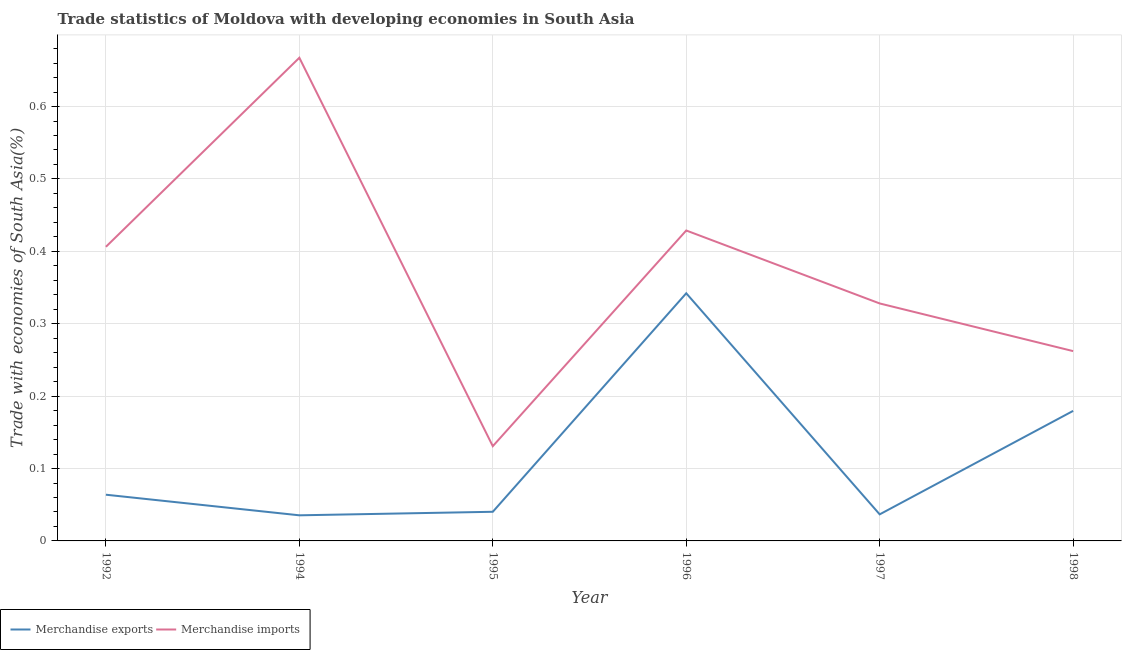Is the number of lines equal to the number of legend labels?
Make the answer very short. Yes. What is the merchandise imports in 1996?
Offer a terse response. 0.43. Across all years, what is the maximum merchandise imports?
Keep it short and to the point. 0.67. Across all years, what is the minimum merchandise imports?
Keep it short and to the point. 0.13. What is the total merchandise imports in the graph?
Ensure brevity in your answer.  2.22. What is the difference between the merchandise exports in 1992 and that in 1998?
Make the answer very short. -0.12. What is the difference between the merchandise imports in 1997 and the merchandise exports in 1996?
Ensure brevity in your answer.  -0.01. What is the average merchandise exports per year?
Make the answer very short. 0.12. In the year 1998, what is the difference between the merchandise exports and merchandise imports?
Provide a short and direct response. -0.08. What is the ratio of the merchandise exports in 1992 to that in 1997?
Keep it short and to the point. 1.74. Is the difference between the merchandise imports in 1995 and 1998 greater than the difference between the merchandise exports in 1995 and 1998?
Your answer should be compact. Yes. What is the difference between the highest and the second highest merchandise imports?
Provide a short and direct response. 0.24. What is the difference between the highest and the lowest merchandise exports?
Provide a succinct answer. 0.31. Is the sum of the merchandise exports in 1994 and 1996 greater than the maximum merchandise imports across all years?
Keep it short and to the point. No. Does the merchandise exports monotonically increase over the years?
Your answer should be compact. No. Is the merchandise exports strictly greater than the merchandise imports over the years?
Your response must be concise. No. Are the values on the major ticks of Y-axis written in scientific E-notation?
Your response must be concise. No. Does the graph contain any zero values?
Offer a terse response. No. Does the graph contain grids?
Provide a succinct answer. Yes. Where does the legend appear in the graph?
Ensure brevity in your answer.  Bottom left. How many legend labels are there?
Your answer should be very brief. 2. What is the title of the graph?
Your response must be concise. Trade statistics of Moldova with developing economies in South Asia. What is the label or title of the X-axis?
Offer a very short reply. Year. What is the label or title of the Y-axis?
Provide a succinct answer. Trade with economies of South Asia(%). What is the Trade with economies of South Asia(%) of Merchandise exports in 1992?
Keep it short and to the point. 0.06. What is the Trade with economies of South Asia(%) in Merchandise imports in 1992?
Offer a very short reply. 0.41. What is the Trade with economies of South Asia(%) of Merchandise exports in 1994?
Make the answer very short. 0.04. What is the Trade with economies of South Asia(%) of Merchandise imports in 1994?
Keep it short and to the point. 0.67. What is the Trade with economies of South Asia(%) in Merchandise exports in 1995?
Offer a terse response. 0.04. What is the Trade with economies of South Asia(%) in Merchandise imports in 1995?
Keep it short and to the point. 0.13. What is the Trade with economies of South Asia(%) of Merchandise exports in 1996?
Make the answer very short. 0.34. What is the Trade with economies of South Asia(%) of Merchandise imports in 1996?
Provide a short and direct response. 0.43. What is the Trade with economies of South Asia(%) of Merchandise exports in 1997?
Your response must be concise. 0.04. What is the Trade with economies of South Asia(%) of Merchandise imports in 1997?
Provide a short and direct response. 0.33. What is the Trade with economies of South Asia(%) in Merchandise exports in 1998?
Provide a succinct answer. 0.18. What is the Trade with economies of South Asia(%) in Merchandise imports in 1998?
Keep it short and to the point. 0.26. Across all years, what is the maximum Trade with economies of South Asia(%) of Merchandise exports?
Your answer should be compact. 0.34. Across all years, what is the maximum Trade with economies of South Asia(%) in Merchandise imports?
Your answer should be compact. 0.67. Across all years, what is the minimum Trade with economies of South Asia(%) in Merchandise exports?
Your answer should be very brief. 0.04. Across all years, what is the minimum Trade with economies of South Asia(%) of Merchandise imports?
Provide a short and direct response. 0.13. What is the total Trade with economies of South Asia(%) of Merchandise exports in the graph?
Your answer should be very brief. 0.7. What is the total Trade with economies of South Asia(%) in Merchandise imports in the graph?
Provide a short and direct response. 2.22. What is the difference between the Trade with economies of South Asia(%) in Merchandise exports in 1992 and that in 1994?
Ensure brevity in your answer.  0.03. What is the difference between the Trade with economies of South Asia(%) in Merchandise imports in 1992 and that in 1994?
Ensure brevity in your answer.  -0.26. What is the difference between the Trade with economies of South Asia(%) in Merchandise exports in 1992 and that in 1995?
Keep it short and to the point. 0.02. What is the difference between the Trade with economies of South Asia(%) of Merchandise imports in 1992 and that in 1995?
Your answer should be very brief. 0.28. What is the difference between the Trade with economies of South Asia(%) in Merchandise exports in 1992 and that in 1996?
Your answer should be very brief. -0.28. What is the difference between the Trade with economies of South Asia(%) in Merchandise imports in 1992 and that in 1996?
Give a very brief answer. -0.02. What is the difference between the Trade with economies of South Asia(%) of Merchandise exports in 1992 and that in 1997?
Provide a short and direct response. 0.03. What is the difference between the Trade with economies of South Asia(%) of Merchandise imports in 1992 and that in 1997?
Offer a terse response. 0.08. What is the difference between the Trade with economies of South Asia(%) of Merchandise exports in 1992 and that in 1998?
Offer a terse response. -0.12. What is the difference between the Trade with economies of South Asia(%) in Merchandise imports in 1992 and that in 1998?
Give a very brief answer. 0.14. What is the difference between the Trade with economies of South Asia(%) in Merchandise exports in 1994 and that in 1995?
Offer a very short reply. -0. What is the difference between the Trade with economies of South Asia(%) of Merchandise imports in 1994 and that in 1995?
Provide a short and direct response. 0.54. What is the difference between the Trade with economies of South Asia(%) in Merchandise exports in 1994 and that in 1996?
Ensure brevity in your answer.  -0.31. What is the difference between the Trade with economies of South Asia(%) of Merchandise imports in 1994 and that in 1996?
Your answer should be compact. 0.24. What is the difference between the Trade with economies of South Asia(%) in Merchandise exports in 1994 and that in 1997?
Offer a very short reply. -0. What is the difference between the Trade with economies of South Asia(%) of Merchandise imports in 1994 and that in 1997?
Provide a succinct answer. 0.34. What is the difference between the Trade with economies of South Asia(%) of Merchandise exports in 1994 and that in 1998?
Offer a very short reply. -0.14. What is the difference between the Trade with economies of South Asia(%) of Merchandise imports in 1994 and that in 1998?
Your answer should be compact. 0.41. What is the difference between the Trade with economies of South Asia(%) of Merchandise exports in 1995 and that in 1996?
Your response must be concise. -0.3. What is the difference between the Trade with economies of South Asia(%) in Merchandise imports in 1995 and that in 1996?
Offer a very short reply. -0.3. What is the difference between the Trade with economies of South Asia(%) of Merchandise exports in 1995 and that in 1997?
Your answer should be very brief. 0. What is the difference between the Trade with economies of South Asia(%) of Merchandise imports in 1995 and that in 1997?
Your answer should be very brief. -0.2. What is the difference between the Trade with economies of South Asia(%) in Merchandise exports in 1995 and that in 1998?
Your answer should be very brief. -0.14. What is the difference between the Trade with economies of South Asia(%) in Merchandise imports in 1995 and that in 1998?
Keep it short and to the point. -0.13. What is the difference between the Trade with economies of South Asia(%) of Merchandise exports in 1996 and that in 1997?
Ensure brevity in your answer.  0.31. What is the difference between the Trade with economies of South Asia(%) in Merchandise imports in 1996 and that in 1997?
Keep it short and to the point. 0.1. What is the difference between the Trade with economies of South Asia(%) in Merchandise exports in 1996 and that in 1998?
Offer a terse response. 0.16. What is the difference between the Trade with economies of South Asia(%) of Merchandise imports in 1996 and that in 1998?
Provide a short and direct response. 0.17. What is the difference between the Trade with economies of South Asia(%) in Merchandise exports in 1997 and that in 1998?
Give a very brief answer. -0.14. What is the difference between the Trade with economies of South Asia(%) of Merchandise imports in 1997 and that in 1998?
Ensure brevity in your answer.  0.07. What is the difference between the Trade with economies of South Asia(%) in Merchandise exports in 1992 and the Trade with economies of South Asia(%) in Merchandise imports in 1994?
Provide a short and direct response. -0.6. What is the difference between the Trade with economies of South Asia(%) of Merchandise exports in 1992 and the Trade with economies of South Asia(%) of Merchandise imports in 1995?
Ensure brevity in your answer.  -0.07. What is the difference between the Trade with economies of South Asia(%) of Merchandise exports in 1992 and the Trade with economies of South Asia(%) of Merchandise imports in 1996?
Keep it short and to the point. -0.36. What is the difference between the Trade with economies of South Asia(%) of Merchandise exports in 1992 and the Trade with economies of South Asia(%) of Merchandise imports in 1997?
Give a very brief answer. -0.26. What is the difference between the Trade with economies of South Asia(%) of Merchandise exports in 1992 and the Trade with economies of South Asia(%) of Merchandise imports in 1998?
Keep it short and to the point. -0.2. What is the difference between the Trade with economies of South Asia(%) of Merchandise exports in 1994 and the Trade with economies of South Asia(%) of Merchandise imports in 1995?
Give a very brief answer. -0.1. What is the difference between the Trade with economies of South Asia(%) of Merchandise exports in 1994 and the Trade with economies of South Asia(%) of Merchandise imports in 1996?
Make the answer very short. -0.39. What is the difference between the Trade with economies of South Asia(%) in Merchandise exports in 1994 and the Trade with economies of South Asia(%) in Merchandise imports in 1997?
Provide a short and direct response. -0.29. What is the difference between the Trade with economies of South Asia(%) in Merchandise exports in 1994 and the Trade with economies of South Asia(%) in Merchandise imports in 1998?
Make the answer very short. -0.23. What is the difference between the Trade with economies of South Asia(%) of Merchandise exports in 1995 and the Trade with economies of South Asia(%) of Merchandise imports in 1996?
Provide a succinct answer. -0.39. What is the difference between the Trade with economies of South Asia(%) in Merchandise exports in 1995 and the Trade with economies of South Asia(%) in Merchandise imports in 1997?
Make the answer very short. -0.29. What is the difference between the Trade with economies of South Asia(%) of Merchandise exports in 1995 and the Trade with economies of South Asia(%) of Merchandise imports in 1998?
Keep it short and to the point. -0.22. What is the difference between the Trade with economies of South Asia(%) in Merchandise exports in 1996 and the Trade with economies of South Asia(%) in Merchandise imports in 1997?
Make the answer very short. 0.01. What is the difference between the Trade with economies of South Asia(%) of Merchandise exports in 1996 and the Trade with economies of South Asia(%) of Merchandise imports in 1998?
Provide a short and direct response. 0.08. What is the difference between the Trade with economies of South Asia(%) of Merchandise exports in 1997 and the Trade with economies of South Asia(%) of Merchandise imports in 1998?
Provide a succinct answer. -0.23. What is the average Trade with economies of South Asia(%) in Merchandise exports per year?
Your answer should be compact. 0.12. What is the average Trade with economies of South Asia(%) in Merchandise imports per year?
Offer a very short reply. 0.37. In the year 1992, what is the difference between the Trade with economies of South Asia(%) in Merchandise exports and Trade with economies of South Asia(%) in Merchandise imports?
Your response must be concise. -0.34. In the year 1994, what is the difference between the Trade with economies of South Asia(%) in Merchandise exports and Trade with economies of South Asia(%) in Merchandise imports?
Keep it short and to the point. -0.63. In the year 1995, what is the difference between the Trade with economies of South Asia(%) of Merchandise exports and Trade with economies of South Asia(%) of Merchandise imports?
Offer a very short reply. -0.09. In the year 1996, what is the difference between the Trade with economies of South Asia(%) in Merchandise exports and Trade with economies of South Asia(%) in Merchandise imports?
Keep it short and to the point. -0.09. In the year 1997, what is the difference between the Trade with economies of South Asia(%) in Merchandise exports and Trade with economies of South Asia(%) in Merchandise imports?
Provide a succinct answer. -0.29. In the year 1998, what is the difference between the Trade with economies of South Asia(%) of Merchandise exports and Trade with economies of South Asia(%) of Merchandise imports?
Offer a very short reply. -0.08. What is the ratio of the Trade with economies of South Asia(%) in Merchandise exports in 1992 to that in 1994?
Your response must be concise. 1.8. What is the ratio of the Trade with economies of South Asia(%) of Merchandise imports in 1992 to that in 1994?
Offer a terse response. 0.61. What is the ratio of the Trade with economies of South Asia(%) of Merchandise exports in 1992 to that in 1995?
Give a very brief answer. 1.59. What is the ratio of the Trade with economies of South Asia(%) of Merchandise imports in 1992 to that in 1995?
Give a very brief answer. 3.1. What is the ratio of the Trade with economies of South Asia(%) in Merchandise exports in 1992 to that in 1996?
Provide a short and direct response. 0.19. What is the ratio of the Trade with economies of South Asia(%) in Merchandise imports in 1992 to that in 1996?
Provide a succinct answer. 0.95. What is the ratio of the Trade with economies of South Asia(%) of Merchandise exports in 1992 to that in 1997?
Provide a succinct answer. 1.74. What is the ratio of the Trade with economies of South Asia(%) of Merchandise imports in 1992 to that in 1997?
Ensure brevity in your answer.  1.24. What is the ratio of the Trade with economies of South Asia(%) of Merchandise exports in 1992 to that in 1998?
Make the answer very short. 0.36. What is the ratio of the Trade with economies of South Asia(%) in Merchandise imports in 1992 to that in 1998?
Give a very brief answer. 1.55. What is the ratio of the Trade with economies of South Asia(%) of Merchandise exports in 1994 to that in 1995?
Your answer should be compact. 0.88. What is the ratio of the Trade with economies of South Asia(%) in Merchandise imports in 1994 to that in 1995?
Provide a succinct answer. 5.1. What is the ratio of the Trade with economies of South Asia(%) in Merchandise exports in 1994 to that in 1996?
Give a very brief answer. 0.1. What is the ratio of the Trade with economies of South Asia(%) of Merchandise imports in 1994 to that in 1996?
Provide a succinct answer. 1.56. What is the ratio of the Trade with economies of South Asia(%) in Merchandise exports in 1994 to that in 1997?
Keep it short and to the point. 0.96. What is the ratio of the Trade with economies of South Asia(%) in Merchandise imports in 1994 to that in 1997?
Provide a short and direct response. 2.03. What is the ratio of the Trade with economies of South Asia(%) in Merchandise exports in 1994 to that in 1998?
Offer a very short reply. 0.2. What is the ratio of the Trade with economies of South Asia(%) in Merchandise imports in 1994 to that in 1998?
Give a very brief answer. 2.55. What is the ratio of the Trade with economies of South Asia(%) in Merchandise exports in 1995 to that in 1996?
Make the answer very short. 0.12. What is the ratio of the Trade with economies of South Asia(%) in Merchandise imports in 1995 to that in 1996?
Your response must be concise. 0.31. What is the ratio of the Trade with economies of South Asia(%) in Merchandise exports in 1995 to that in 1997?
Keep it short and to the point. 1.1. What is the ratio of the Trade with economies of South Asia(%) in Merchandise imports in 1995 to that in 1997?
Keep it short and to the point. 0.4. What is the ratio of the Trade with economies of South Asia(%) of Merchandise exports in 1995 to that in 1998?
Provide a short and direct response. 0.22. What is the ratio of the Trade with economies of South Asia(%) of Merchandise imports in 1995 to that in 1998?
Offer a very short reply. 0.5. What is the ratio of the Trade with economies of South Asia(%) of Merchandise exports in 1996 to that in 1997?
Offer a terse response. 9.32. What is the ratio of the Trade with economies of South Asia(%) of Merchandise imports in 1996 to that in 1997?
Provide a succinct answer. 1.31. What is the ratio of the Trade with economies of South Asia(%) in Merchandise exports in 1996 to that in 1998?
Keep it short and to the point. 1.9. What is the ratio of the Trade with economies of South Asia(%) of Merchandise imports in 1996 to that in 1998?
Offer a terse response. 1.64. What is the ratio of the Trade with economies of South Asia(%) of Merchandise exports in 1997 to that in 1998?
Offer a very short reply. 0.2. What is the ratio of the Trade with economies of South Asia(%) in Merchandise imports in 1997 to that in 1998?
Offer a terse response. 1.25. What is the difference between the highest and the second highest Trade with economies of South Asia(%) in Merchandise exports?
Provide a succinct answer. 0.16. What is the difference between the highest and the second highest Trade with economies of South Asia(%) in Merchandise imports?
Your answer should be very brief. 0.24. What is the difference between the highest and the lowest Trade with economies of South Asia(%) in Merchandise exports?
Provide a short and direct response. 0.31. What is the difference between the highest and the lowest Trade with economies of South Asia(%) of Merchandise imports?
Ensure brevity in your answer.  0.54. 